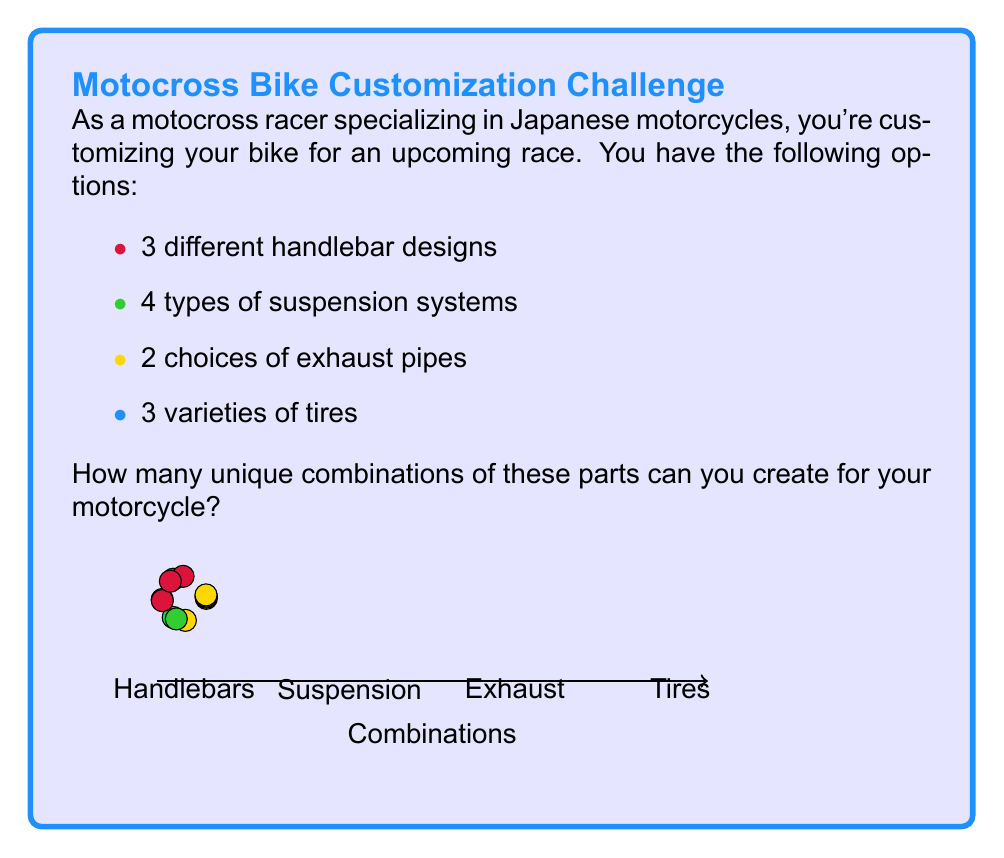Help me with this question. To solve this problem, we'll use the multiplication principle of counting. This principle states that if we have a sequence of choices, and the number of options for each choice is independent of the others, then the total number of possible outcomes is the product of the number of options for each choice.

Let's break it down step-by-step:

1) Handlebars: 3 options
2) Suspension systems: 4 options
3) Exhaust pipes: 2 options
4) Tires: 3 options

Now, for each handlebar choice, we can choose any of the suspension systems, and for each of those combinations, we can choose either exhaust pipe, and for each of those, we can choose any of the tire options.

Therefore, the total number of unique combinations is:

$$ 3 \times 4 \times 2 \times 3 = 72 $$

We can also express this mathematically as:

$$ \text{Total Combinations} = \prod_{i=1}^{n} \text{Options}_i $$

Where $n$ is the number of customizable parts (in this case, 4), and $\text{Options}_i$ is the number of options for the $i$-th part.
Answer: 72 combinations 